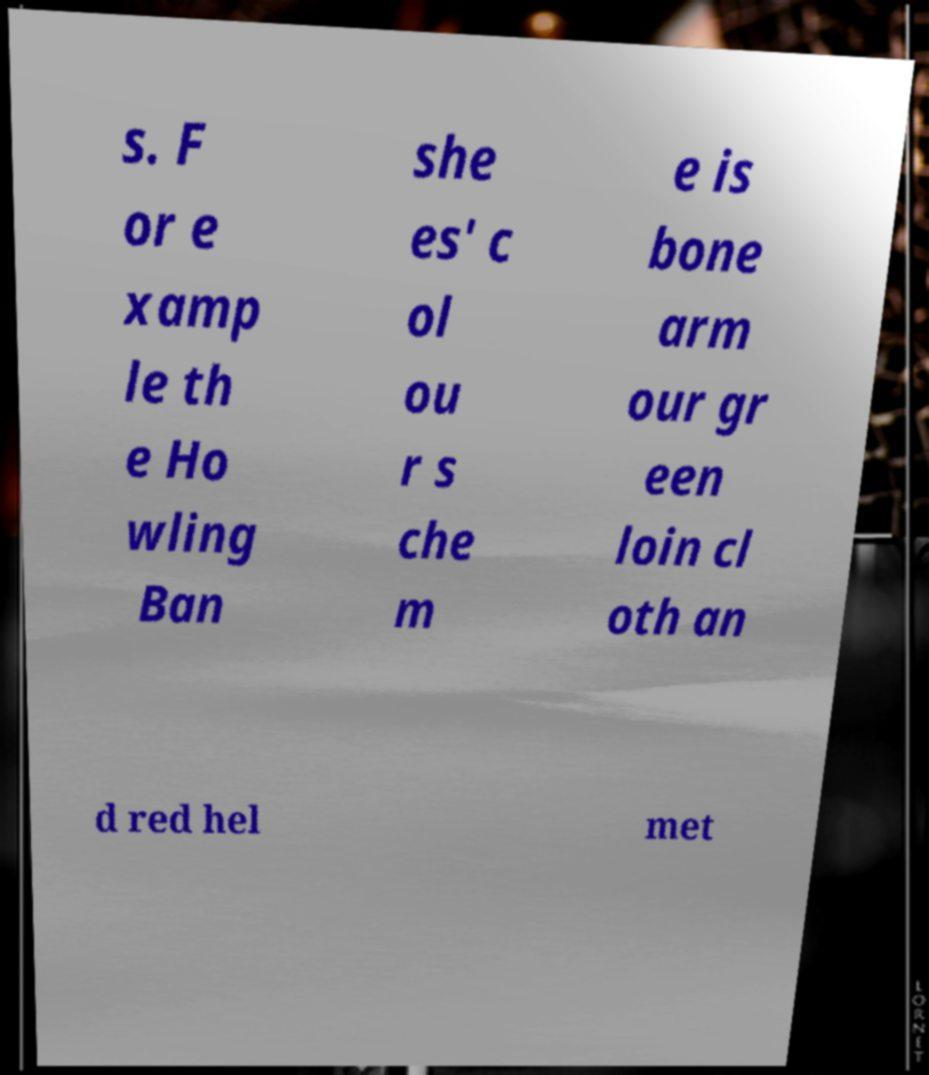Can you accurately transcribe the text from the provided image for me? s. F or e xamp le th e Ho wling Ban she es' c ol ou r s che m e is bone arm our gr een loin cl oth an d red hel met 